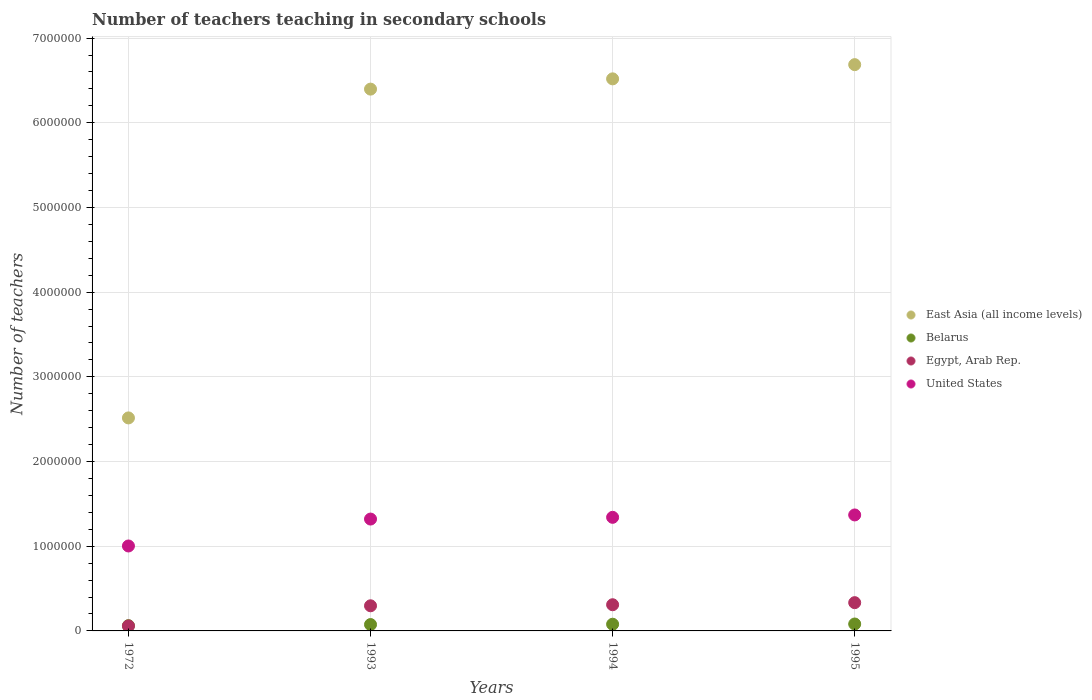How many different coloured dotlines are there?
Your answer should be compact. 4. Is the number of dotlines equal to the number of legend labels?
Offer a very short reply. Yes. What is the number of teachers teaching in secondary schools in East Asia (all income levels) in 1993?
Offer a terse response. 6.40e+06. Across all years, what is the maximum number of teachers teaching in secondary schools in United States?
Make the answer very short. 1.37e+06. Across all years, what is the minimum number of teachers teaching in secondary schools in United States?
Give a very brief answer. 1.00e+06. In which year was the number of teachers teaching in secondary schools in Belarus maximum?
Give a very brief answer. 1995. What is the total number of teachers teaching in secondary schools in East Asia (all income levels) in the graph?
Provide a short and direct response. 2.21e+07. What is the difference between the number of teachers teaching in secondary schools in United States in 1972 and that in 1993?
Make the answer very short. -3.18e+05. What is the difference between the number of teachers teaching in secondary schools in East Asia (all income levels) in 1994 and the number of teachers teaching in secondary schools in Egypt, Arab Rep. in 1995?
Make the answer very short. 6.18e+06. What is the average number of teachers teaching in secondary schools in Egypt, Arab Rep. per year?
Provide a short and direct response. 2.50e+05. In the year 1995, what is the difference between the number of teachers teaching in secondary schools in Belarus and number of teachers teaching in secondary schools in East Asia (all income levels)?
Keep it short and to the point. -6.60e+06. In how many years, is the number of teachers teaching in secondary schools in United States greater than 5800000?
Your answer should be compact. 0. What is the ratio of the number of teachers teaching in secondary schools in United States in 1993 to that in 1994?
Offer a terse response. 0.98. Is the number of teachers teaching in secondary schools in Egypt, Arab Rep. in 1993 less than that in 1995?
Your answer should be compact. Yes. Is the difference between the number of teachers teaching in secondary schools in Belarus in 1972 and 1995 greater than the difference between the number of teachers teaching in secondary schools in East Asia (all income levels) in 1972 and 1995?
Give a very brief answer. Yes. What is the difference between the highest and the second highest number of teachers teaching in secondary schools in Belarus?
Your answer should be very brief. 2700. What is the difference between the highest and the lowest number of teachers teaching in secondary schools in Belarus?
Keep it short and to the point. 1.95e+04. In how many years, is the number of teachers teaching in secondary schools in Egypt, Arab Rep. greater than the average number of teachers teaching in secondary schools in Egypt, Arab Rep. taken over all years?
Keep it short and to the point. 3. Is the sum of the number of teachers teaching in secondary schools in United States in 1993 and 1995 greater than the maximum number of teachers teaching in secondary schools in East Asia (all income levels) across all years?
Make the answer very short. No. Is it the case that in every year, the sum of the number of teachers teaching in secondary schools in United States and number of teachers teaching in secondary schools in Belarus  is greater than the number of teachers teaching in secondary schools in East Asia (all income levels)?
Ensure brevity in your answer.  No. Does the number of teachers teaching in secondary schools in East Asia (all income levels) monotonically increase over the years?
Provide a short and direct response. Yes. Is the number of teachers teaching in secondary schools in United States strictly greater than the number of teachers teaching in secondary schools in Belarus over the years?
Ensure brevity in your answer.  Yes. Is the number of teachers teaching in secondary schools in East Asia (all income levels) strictly less than the number of teachers teaching in secondary schools in Belarus over the years?
Provide a succinct answer. No. How many dotlines are there?
Your response must be concise. 4. How many years are there in the graph?
Offer a terse response. 4. What is the difference between two consecutive major ticks on the Y-axis?
Provide a short and direct response. 1.00e+06. How many legend labels are there?
Keep it short and to the point. 4. What is the title of the graph?
Your response must be concise. Number of teachers teaching in secondary schools. Does "Czech Republic" appear as one of the legend labels in the graph?
Your answer should be very brief. No. What is the label or title of the Y-axis?
Give a very brief answer. Number of teachers. What is the Number of teachers in East Asia (all income levels) in 1972?
Your response must be concise. 2.52e+06. What is the Number of teachers of Belarus in 1972?
Offer a very short reply. 6.22e+04. What is the Number of teachers of Egypt, Arab Rep. in 1972?
Your response must be concise. 5.86e+04. What is the Number of teachers of United States in 1972?
Ensure brevity in your answer.  1.00e+06. What is the Number of teachers in East Asia (all income levels) in 1993?
Ensure brevity in your answer.  6.40e+06. What is the Number of teachers of Belarus in 1993?
Give a very brief answer. 7.52e+04. What is the Number of teachers of Egypt, Arab Rep. in 1993?
Offer a terse response. 2.97e+05. What is the Number of teachers in United States in 1993?
Offer a terse response. 1.32e+06. What is the Number of teachers of East Asia (all income levels) in 1994?
Keep it short and to the point. 6.52e+06. What is the Number of teachers of Belarus in 1994?
Offer a terse response. 7.90e+04. What is the Number of teachers of Egypt, Arab Rep. in 1994?
Ensure brevity in your answer.  3.09e+05. What is the Number of teachers of United States in 1994?
Offer a very short reply. 1.34e+06. What is the Number of teachers of East Asia (all income levels) in 1995?
Your answer should be compact. 6.69e+06. What is the Number of teachers of Belarus in 1995?
Keep it short and to the point. 8.17e+04. What is the Number of teachers of Egypt, Arab Rep. in 1995?
Provide a short and direct response. 3.34e+05. What is the Number of teachers in United States in 1995?
Keep it short and to the point. 1.37e+06. Across all years, what is the maximum Number of teachers in East Asia (all income levels)?
Your response must be concise. 6.69e+06. Across all years, what is the maximum Number of teachers of Belarus?
Provide a succinct answer. 8.17e+04. Across all years, what is the maximum Number of teachers in Egypt, Arab Rep.?
Ensure brevity in your answer.  3.34e+05. Across all years, what is the maximum Number of teachers of United States?
Your answer should be very brief. 1.37e+06. Across all years, what is the minimum Number of teachers in East Asia (all income levels)?
Keep it short and to the point. 2.52e+06. Across all years, what is the minimum Number of teachers in Belarus?
Offer a very short reply. 6.22e+04. Across all years, what is the minimum Number of teachers in Egypt, Arab Rep.?
Provide a succinct answer. 5.86e+04. Across all years, what is the minimum Number of teachers in United States?
Keep it short and to the point. 1.00e+06. What is the total Number of teachers in East Asia (all income levels) in the graph?
Your answer should be compact. 2.21e+07. What is the total Number of teachers of Belarus in the graph?
Offer a terse response. 2.98e+05. What is the total Number of teachers of Egypt, Arab Rep. in the graph?
Provide a succinct answer. 9.98e+05. What is the total Number of teachers in United States in the graph?
Offer a terse response. 5.03e+06. What is the difference between the Number of teachers of East Asia (all income levels) in 1972 and that in 1993?
Keep it short and to the point. -3.88e+06. What is the difference between the Number of teachers in Belarus in 1972 and that in 1993?
Keep it short and to the point. -1.30e+04. What is the difference between the Number of teachers in Egypt, Arab Rep. in 1972 and that in 1993?
Your answer should be very brief. -2.38e+05. What is the difference between the Number of teachers of United States in 1972 and that in 1993?
Keep it short and to the point. -3.18e+05. What is the difference between the Number of teachers in East Asia (all income levels) in 1972 and that in 1994?
Your answer should be compact. -4.00e+06. What is the difference between the Number of teachers in Belarus in 1972 and that in 1994?
Give a very brief answer. -1.68e+04. What is the difference between the Number of teachers in Egypt, Arab Rep. in 1972 and that in 1994?
Provide a succinct answer. -2.51e+05. What is the difference between the Number of teachers in United States in 1972 and that in 1994?
Make the answer very short. -3.38e+05. What is the difference between the Number of teachers of East Asia (all income levels) in 1972 and that in 1995?
Provide a short and direct response. -4.17e+06. What is the difference between the Number of teachers in Belarus in 1972 and that in 1995?
Your response must be concise. -1.95e+04. What is the difference between the Number of teachers of Egypt, Arab Rep. in 1972 and that in 1995?
Keep it short and to the point. -2.75e+05. What is the difference between the Number of teachers in United States in 1972 and that in 1995?
Give a very brief answer. -3.66e+05. What is the difference between the Number of teachers in East Asia (all income levels) in 1993 and that in 1994?
Offer a terse response. -1.21e+05. What is the difference between the Number of teachers in Belarus in 1993 and that in 1994?
Provide a short and direct response. -3800. What is the difference between the Number of teachers in Egypt, Arab Rep. in 1993 and that in 1994?
Ensure brevity in your answer.  -1.25e+04. What is the difference between the Number of teachers in United States in 1993 and that in 1994?
Give a very brief answer. -2.05e+04. What is the difference between the Number of teachers in East Asia (all income levels) in 1993 and that in 1995?
Your answer should be compact. -2.89e+05. What is the difference between the Number of teachers of Belarus in 1993 and that in 1995?
Provide a short and direct response. -6500. What is the difference between the Number of teachers of Egypt, Arab Rep. in 1993 and that in 1995?
Provide a succinct answer. -3.70e+04. What is the difference between the Number of teachers in United States in 1993 and that in 1995?
Your answer should be compact. -4.85e+04. What is the difference between the Number of teachers in East Asia (all income levels) in 1994 and that in 1995?
Keep it short and to the point. -1.68e+05. What is the difference between the Number of teachers in Belarus in 1994 and that in 1995?
Ensure brevity in your answer.  -2700. What is the difference between the Number of teachers in Egypt, Arab Rep. in 1994 and that in 1995?
Offer a very short reply. -2.46e+04. What is the difference between the Number of teachers of United States in 1994 and that in 1995?
Provide a short and direct response. -2.80e+04. What is the difference between the Number of teachers in East Asia (all income levels) in 1972 and the Number of teachers in Belarus in 1993?
Provide a succinct answer. 2.44e+06. What is the difference between the Number of teachers in East Asia (all income levels) in 1972 and the Number of teachers in Egypt, Arab Rep. in 1993?
Your answer should be compact. 2.22e+06. What is the difference between the Number of teachers in East Asia (all income levels) in 1972 and the Number of teachers in United States in 1993?
Provide a succinct answer. 1.19e+06. What is the difference between the Number of teachers in Belarus in 1972 and the Number of teachers in Egypt, Arab Rep. in 1993?
Make the answer very short. -2.34e+05. What is the difference between the Number of teachers in Belarus in 1972 and the Number of teachers in United States in 1993?
Provide a succinct answer. -1.26e+06. What is the difference between the Number of teachers of Egypt, Arab Rep. in 1972 and the Number of teachers of United States in 1993?
Your answer should be compact. -1.26e+06. What is the difference between the Number of teachers in East Asia (all income levels) in 1972 and the Number of teachers in Belarus in 1994?
Offer a terse response. 2.44e+06. What is the difference between the Number of teachers of East Asia (all income levels) in 1972 and the Number of teachers of Egypt, Arab Rep. in 1994?
Your answer should be compact. 2.21e+06. What is the difference between the Number of teachers in East Asia (all income levels) in 1972 and the Number of teachers in United States in 1994?
Provide a succinct answer. 1.17e+06. What is the difference between the Number of teachers of Belarus in 1972 and the Number of teachers of Egypt, Arab Rep. in 1994?
Offer a terse response. -2.47e+05. What is the difference between the Number of teachers of Belarus in 1972 and the Number of teachers of United States in 1994?
Offer a terse response. -1.28e+06. What is the difference between the Number of teachers of Egypt, Arab Rep. in 1972 and the Number of teachers of United States in 1994?
Make the answer very short. -1.28e+06. What is the difference between the Number of teachers of East Asia (all income levels) in 1972 and the Number of teachers of Belarus in 1995?
Provide a succinct answer. 2.43e+06. What is the difference between the Number of teachers in East Asia (all income levels) in 1972 and the Number of teachers in Egypt, Arab Rep. in 1995?
Your answer should be very brief. 2.18e+06. What is the difference between the Number of teachers of East Asia (all income levels) in 1972 and the Number of teachers of United States in 1995?
Ensure brevity in your answer.  1.15e+06. What is the difference between the Number of teachers of Belarus in 1972 and the Number of teachers of Egypt, Arab Rep. in 1995?
Ensure brevity in your answer.  -2.72e+05. What is the difference between the Number of teachers of Belarus in 1972 and the Number of teachers of United States in 1995?
Keep it short and to the point. -1.31e+06. What is the difference between the Number of teachers in Egypt, Arab Rep. in 1972 and the Number of teachers in United States in 1995?
Your answer should be very brief. -1.31e+06. What is the difference between the Number of teachers of East Asia (all income levels) in 1993 and the Number of teachers of Belarus in 1994?
Provide a succinct answer. 6.32e+06. What is the difference between the Number of teachers of East Asia (all income levels) in 1993 and the Number of teachers of Egypt, Arab Rep. in 1994?
Provide a short and direct response. 6.09e+06. What is the difference between the Number of teachers in East Asia (all income levels) in 1993 and the Number of teachers in United States in 1994?
Provide a short and direct response. 5.06e+06. What is the difference between the Number of teachers in Belarus in 1993 and the Number of teachers in Egypt, Arab Rep. in 1994?
Offer a terse response. -2.34e+05. What is the difference between the Number of teachers in Belarus in 1993 and the Number of teachers in United States in 1994?
Ensure brevity in your answer.  -1.27e+06. What is the difference between the Number of teachers in Egypt, Arab Rep. in 1993 and the Number of teachers in United States in 1994?
Your response must be concise. -1.04e+06. What is the difference between the Number of teachers of East Asia (all income levels) in 1993 and the Number of teachers of Belarus in 1995?
Offer a terse response. 6.32e+06. What is the difference between the Number of teachers of East Asia (all income levels) in 1993 and the Number of teachers of Egypt, Arab Rep. in 1995?
Provide a short and direct response. 6.06e+06. What is the difference between the Number of teachers of East Asia (all income levels) in 1993 and the Number of teachers of United States in 1995?
Provide a succinct answer. 5.03e+06. What is the difference between the Number of teachers in Belarus in 1993 and the Number of teachers in Egypt, Arab Rep. in 1995?
Offer a terse response. -2.59e+05. What is the difference between the Number of teachers of Belarus in 1993 and the Number of teachers of United States in 1995?
Give a very brief answer. -1.29e+06. What is the difference between the Number of teachers in Egypt, Arab Rep. in 1993 and the Number of teachers in United States in 1995?
Your answer should be compact. -1.07e+06. What is the difference between the Number of teachers in East Asia (all income levels) in 1994 and the Number of teachers in Belarus in 1995?
Provide a succinct answer. 6.44e+06. What is the difference between the Number of teachers in East Asia (all income levels) in 1994 and the Number of teachers in Egypt, Arab Rep. in 1995?
Your answer should be very brief. 6.18e+06. What is the difference between the Number of teachers of East Asia (all income levels) in 1994 and the Number of teachers of United States in 1995?
Give a very brief answer. 5.15e+06. What is the difference between the Number of teachers of Belarus in 1994 and the Number of teachers of Egypt, Arab Rep. in 1995?
Your answer should be compact. -2.55e+05. What is the difference between the Number of teachers of Belarus in 1994 and the Number of teachers of United States in 1995?
Your response must be concise. -1.29e+06. What is the difference between the Number of teachers of Egypt, Arab Rep. in 1994 and the Number of teachers of United States in 1995?
Your response must be concise. -1.06e+06. What is the average Number of teachers in East Asia (all income levels) per year?
Your response must be concise. 5.53e+06. What is the average Number of teachers of Belarus per year?
Give a very brief answer. 7.45e+04. What is the average Number of teachers in Egypt, Arab Rep. per year?
Your answer should be compact. 2.50e+05. What is the average Number of teachers of United States per year?
Your answer should be compact. 1.26e+06. In the year 1972, what is the difference between the Number of teachers of East Asia (all income levels) and Number of teachers of Belarus?
Keep it short and to the point. 2.45e+06. In the year 1972, what is the difference between the Number of teachers in East Asia (all income levels) and Number of teachers in Egypt, Arab Rep.?
Provide a succinct answer. 2.46e+06. In the year 1972, what is the difference between the Number of teachers of East Asia (all income levels) and Number of teachers of United States?
Give a very brief answer. 1.51e+06. In the year 1972, what is the difference between the Number of teachers in Belarus and Number of teachers in Egypt, Arab Rep.?
Make the answer very short. 3615. In the year 1972, what is the difference between the Number of teachers in Belarus and Number of teachers in United States?
Provide a succinct answer. -9.41e+05. In the year 1972, what is the difference between the Number of teachers of Egypt, Arab Rep. and Number of teachers of United States?
Your response must be concise. -9.44e+05. In the year 1993, what is the difference between the Number of teachers of East Asia (all income levels) and Number of teachers of Belarus?
Offer a very short reply. 6.32e+06. In the year 1993, what is the difference between the Number of teachers in East Asia (all income levels) and Number of teachers in Egypt, Arab Rep.?
Keep it short and to the point. 6.10e+06. In the year 1993, what is the difference between the Number of teachers of East Asia (all income levels) and Number of teachers of United States?
Your answer should be very brief. 5.08e+06. In the year 1993, what is the difference between the Number of teachers in Belarus and Number of teachers in Egypt, Arab Rep.?
Your response must be concise. -2.21e+05. In the year 1993, what is the difference between the Number of teachers in Belarus and Number of teachers in United States?
Your answer should be compact. -1.25e+06. In the year 1993, what is the difference between the Number of teachers of Egypt, Arab Rep. and Number of teachers of United States?
Your answer should be very brief. -1.02e+06. In the year 1994, what is the difference between the Number of teachers of East Asia (all income levels) and Number of teachers of Belarus?
Keep it short and to the point. 6.44e+06. In the year 1994, what is the difference between the Number of teachers in East Asia (all income levels) and Number of teachers in Egypt, Arab Rep.?
Ensure brevity in your answer.  6.21e+06. In the year 1994, what is the difference between the Number of teachers of East Asia (all income levels) and Number of teachers of United States?
Your answer should be compact. 5.18e+06. In the year 1994, what is the difference between the Number of teachers in Belarus and Number of teachers in Egypt, Arab Rep.?
Your response must be concise. -2.30e+05. In the year 1994, what is the difference between the Number of teachers in Belarus and Number of teachers in United States?
Provide a succinct answer. -1.26e+06. In the year 1994, what is the difference between the Number of teachers of Egypt, Arab Rep. and Number of teachers of United States?
Your answer should be very brief. -1.03e+06. In the year 1995, what is the difference between the Number of teachers of East Asia (all income levels) and Number of teachers of Belarus?
Provide a succinct answer. 6.60e+06. In the year 1995, what is the difference between the Number of teachers of East Asia (all income levels) and Number of teachers of Egypt, Arab Rep.?
Ensure brevity in your answer.  6.35e+06. In the year 1995, what is the difference between the Number of teachers in East Asia (all income levels) and Number of teachers in United States?
Offer a terse response. 5.32e+06. In the year 1995, what is the difference between the Number of teachers in Belarus and Number of teachers in Egypt, Arab Rep.?
Ensure brevity in your answer.  -2.52e+05. In the year 1995, what is the difference between the Number of teachers of Belarus and Number of teachers of United States?
Ensure brevity in your answer.  -1.29e+06. In the year 1995, what is the difference between the Number of teachers of Egypt, Arab Rep. and Number of teachers of United States?
Provide a short and direct response. -1.04e+06. What is the ratio of the Number of teachers of East Asia (all income levels) in 1972 to that in 1993?
Give a very brief answer. 0.39. What is the ratio of the Number of teachers of Belarus in 1972 to that in 1993?
Keep it short and to the point. 0.83. What is the ratio of the Number of teachers of Egypt, Arab Rep. in 1972 to that in 1993?
Ensure brevity in your answer.  0.2. What is the ratio of the Number of teachers in United States in 1972 to that in 1993?
Provide a short and direct response. 0.76. What is the ratio of the Number of teachers in East Asia (all income levels) in 1972 to that in 1994?
Provide a succinct answer. 0.39. What is the ratio of the Number of teachers in Belarus in 1972 to that in 1994?
Provide a short and direct response. 0.79. What is the ratio of the Number of teachers of Egypt, Arab Rep. in 1972 to that in 1994?
Offer a terse response. 0.19. What is the ratio of the Number of teachers in United States in 1972 to that in 1994?
Make the answer very short. 0.75. What is the ratio of the Number of teachers of East Asia (all income levels) in 1972 to that in 1995?
Keep it short and to the point. 0.38. What is the ratio of the Number of teachers of Belarus in 1972 to that in 1995?
Ensure brevity in your answer.  0.76. What is the ratio of the Number of teachers of Egypt, Arab Rep. in 1972 to that in 1995?
Offer a very short reply. 0.18. What is the ratio of the Number of teachers of United States in 1972 to that in 1995?
Provide a succinct answer. 0.73. What is the ratio of the Number of teachers of East Asia (all income levels) in 1993 to that in 1994?
Provide a short and direct response. 0.98. What is the ratio of the Number of teachers in Belarus in 1993 to that in 1994?
Offer a very short reply. 0.95. What is the ratio of the Number of teachers of Egypt, Arab Rep. in 1993 to that in 1994?
Provide a short and direct response. 0.96. What is the ratio of the Number of teachers of United States in 1993 to that in 1994?
Your answer should be very brief. 0.98. What is the ratio of the Number of teachers in East Asia (all income levels) in 1993 to that in 1995?
Your answer should be very brief. 0.96. What is the ratio of the Number of teachers in Belarus in 1993 to that in 1995?
Offer a terse response. 0.92. What is the ratio of the Number of teachers of Egypt, Arab Rep. in 1993 to that in 1995?
Make the answer very short. 0.89. What is the ratio of the Number of teachers of United States in 1993 to that in 1995?
Ensure brevity in your answer.  0.96. What is the ratio of the Number of teachers in East Asia (all income levels) in 1994 to that in 1995?
Offer a very short reply. 0.97. What is the ratio of the Number of teachers of Belarus in 1994 to that in 1995?
Keep it short and to the point. 0.97. What is the ratio of the Number of teachers of Egypt, Arab Rep. in 1994 to that in 1995?
Provide a succinct answer. 0.93. What is the ratio of the Number of teachers of United States in 1994 to that in 1995?
Make the answer very short. 0.98. What is the difference between the highest and the second highest Number of teachers in East Asia (all income levels)?
Keep it short and to the point. 1.68e+05. What is the difference between the highest and the second highest Number of teachers of Belarus?
Your answer should be very brief. 2700. What is the difference between the highest and the second highest Number of teachers of Egypt, Arab Rep.?
Provide a succinct answer. 2.46e+04. What is the difference between the highest and the second highest Number of teachers of United States?
Keep it short and to the point. 2.80e+04. What is the difference between the highest and the lowest Number of teachers in East Asia (all income levels)?
Make the answer very short. 4.17e+06. What is the difference between the highest and the lowest Number of teachers in Belarus?
Give a very brief answer. 1.95e+04. What is the difference between the highest and the lowest Number of teachers of Egypt, Arab Rep.?
Your response must be concise. 2.75e+05. What is the difference between the highest and the lowest Number of teachers of United States?
Make the answer very short. 3.66e+05. 